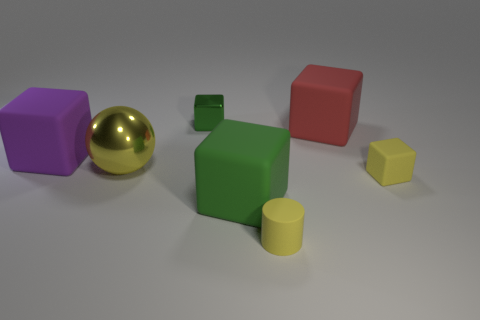Subtract all purple cubes. How many cubes are left? 4 Subtract all small metal cubes. How many cubes are left? 4 Subtract 1 cubes. How many cubes are left? 4 Subtract all red spheres. Subtract all red cylinders. How many spheres are left? 1 Add 1 big red matte objects. How many objects exist? 8 Subtract all cubes. How many objects are left? 2 Subtract 0 gray cubes. How many objects are left? 7 Subtract all tiny yellow cylinders. Subtract all spheres. How many objects are left? 5 Add 3 large green rubber blocks. How many large green rubber blocks are left? 4 Add 5 big purple rubber things. How many big purple rubber things exist? 6 